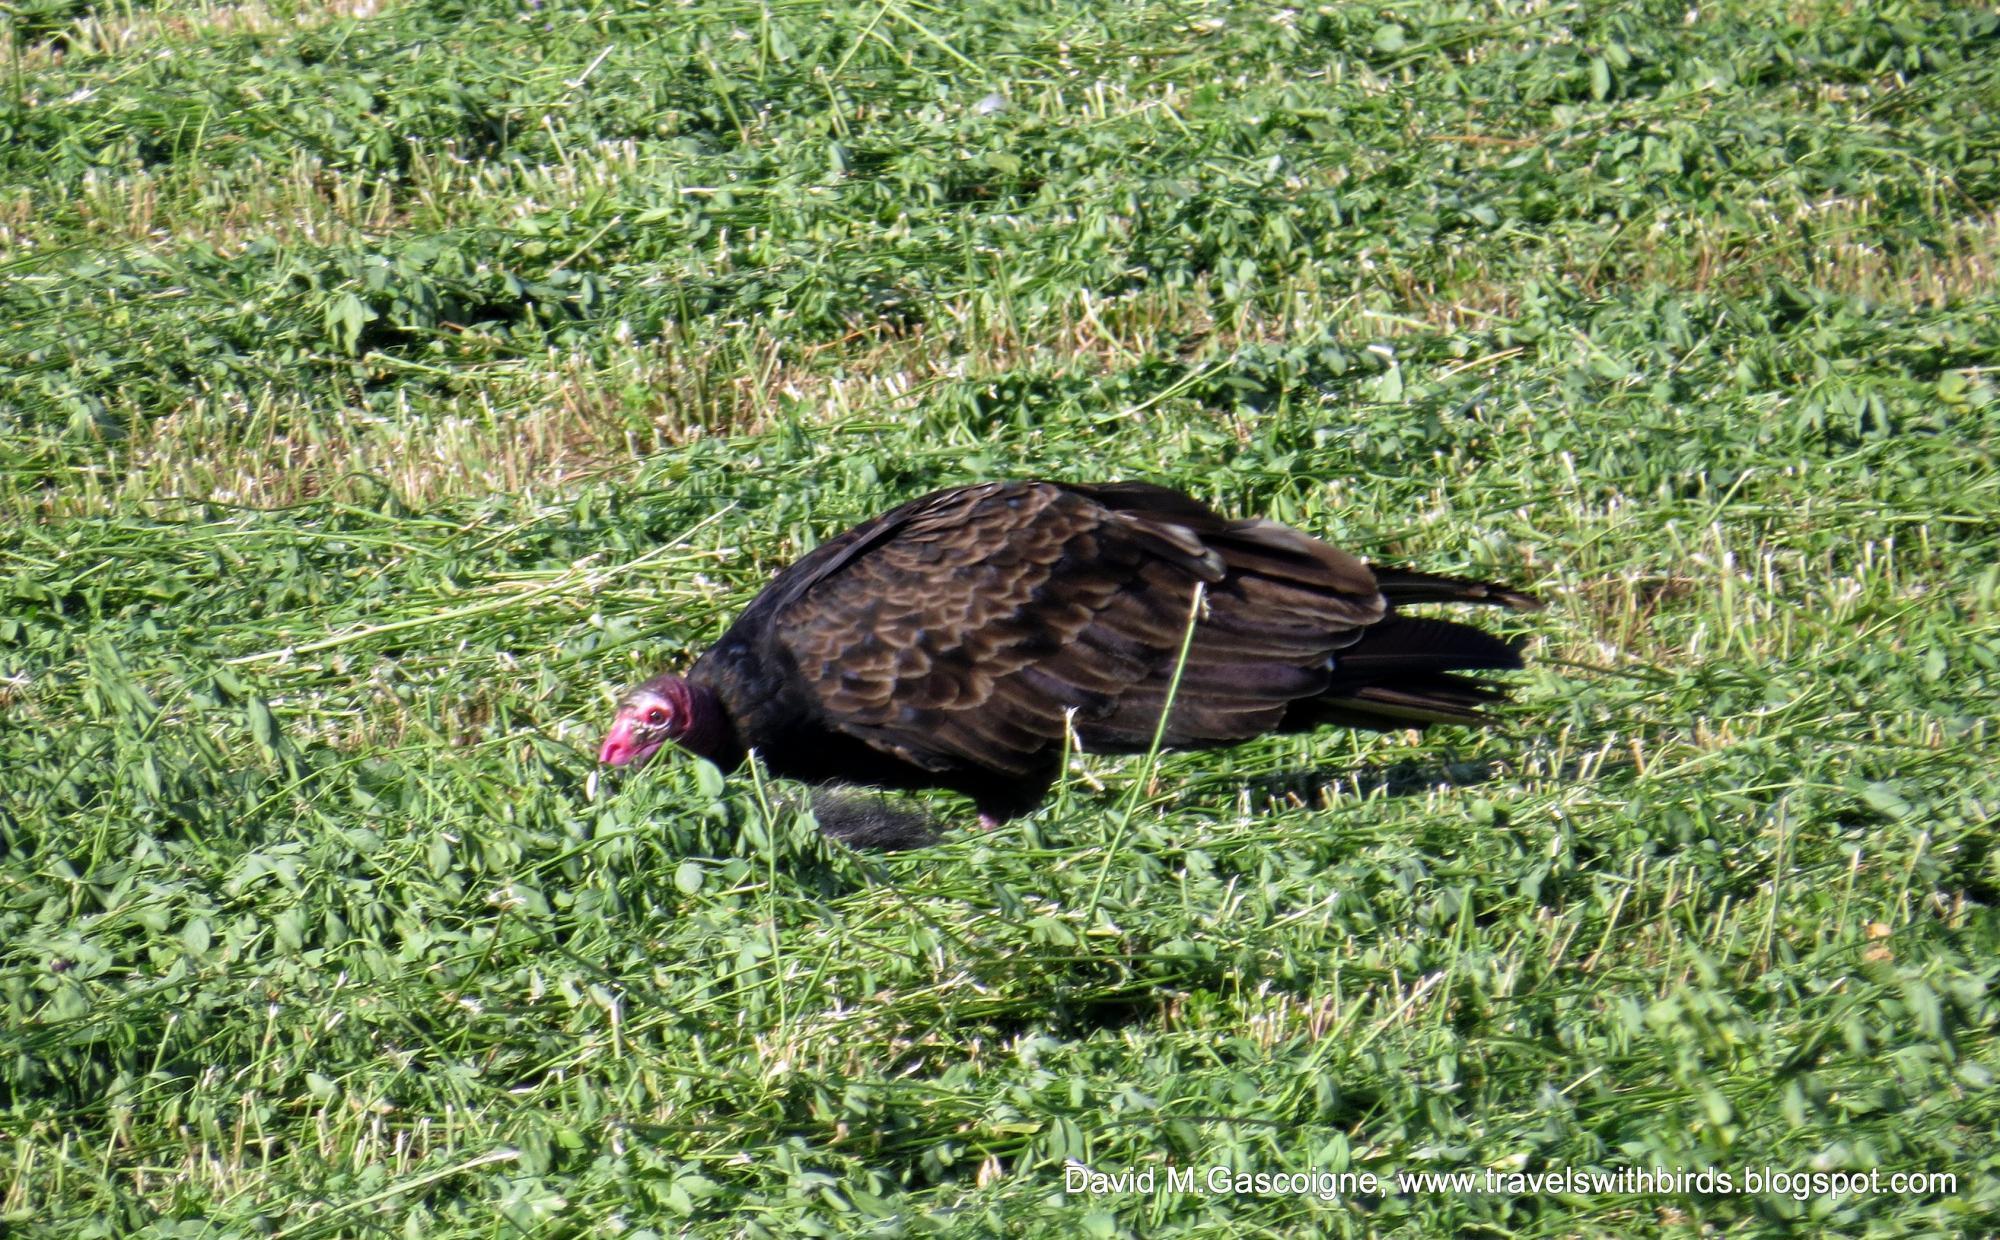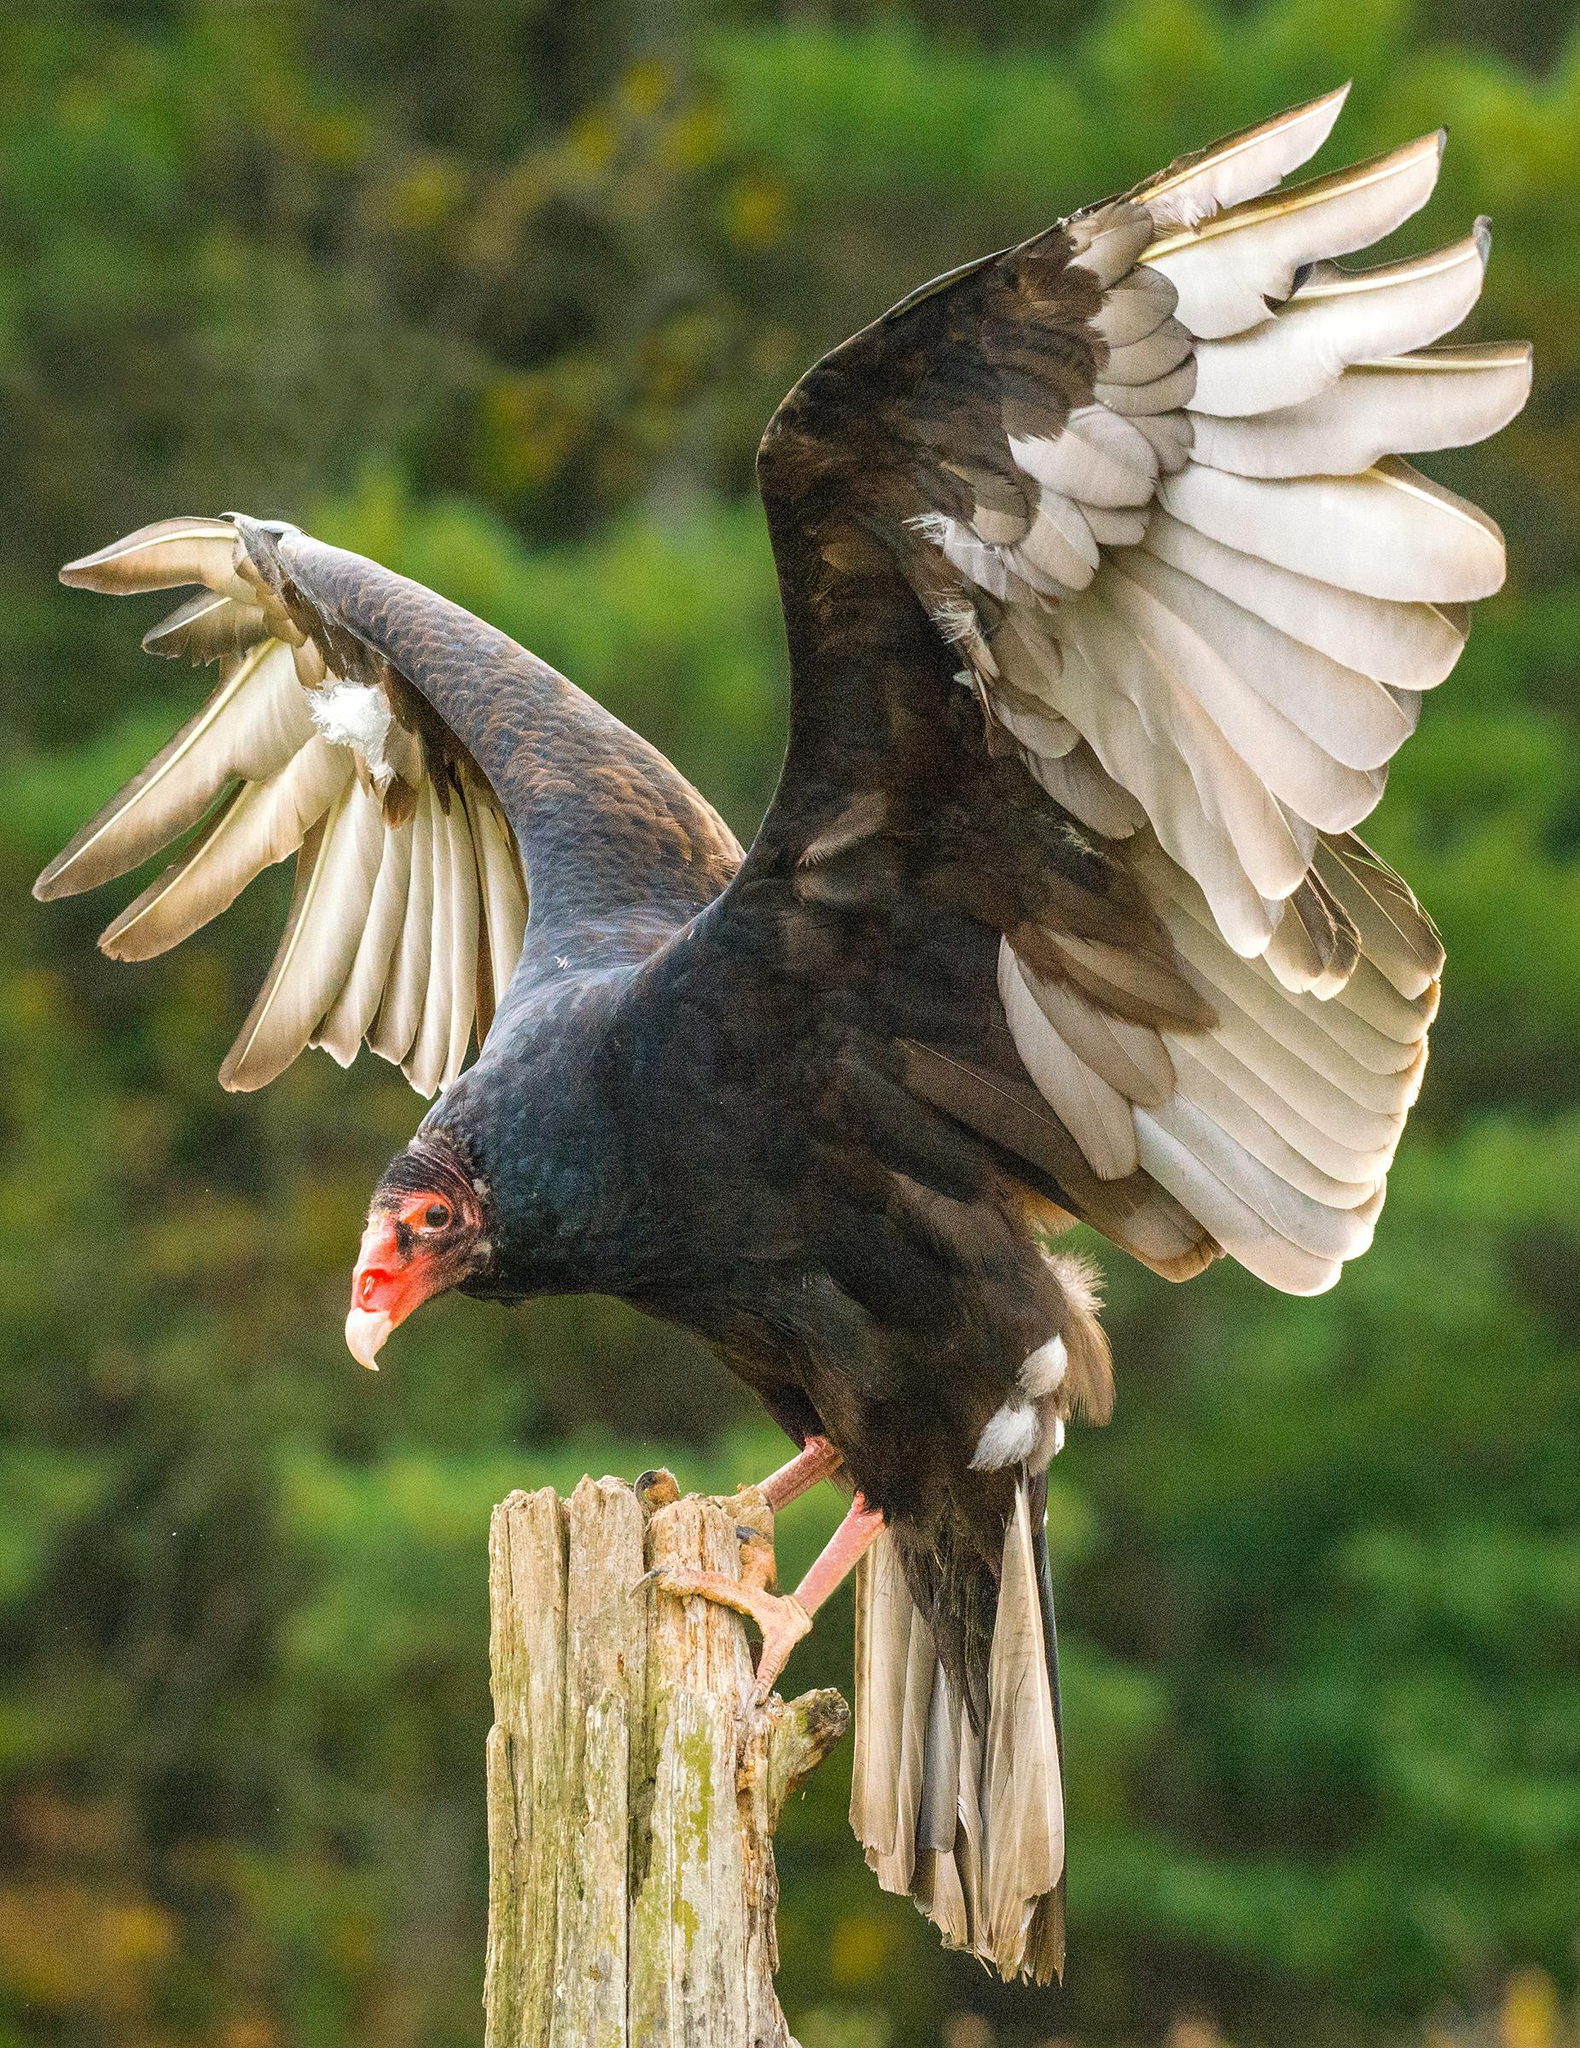The first image is the image on the left, the second image is the image on the right. Evaluate the accuracy of this statement regarding the images: "The left and right image contains the same number of vultures.". Is it true? Answer yes or no. Yes. The first image is the image on the left, the second image is the image on the right. Given the left and right images, does the statement "The left image features one vulture with tucked wings, and the right image features one leftward-facing vulture with spread wings." hold true? Answer yes or no. Yes. 